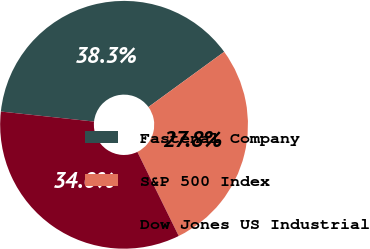<chart> <loc_0><loc_0><loc_500><loc_500><pie_chart><fcel>Fastenal Company<fcel>S&P 500 Index<fcel>Dow Jones US Industrial<nl><fcel>38.27%<fcel>27.75%<fcel>33.98%<nl></chart> 